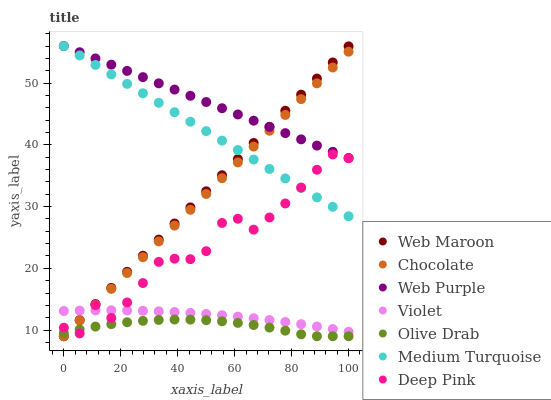Does Olive Drab have the minimum area under the curve?
Answer yes or no. Yes. Does Web Purple have the maximum area under the curve?
Answer yes or no. Yes. Does Web Maroon have the minimum area under the curve?
Answer yes or no. No. Does Web Maroon have the maximum area under the curve?
Answer yes or no. No. Is Chocolate the smoothest?
Answer yes or no. Yes. Is Deep Pink the roughest?
Answer yes or no. Yes. Is Web Maroon the smoothest?
Answer yes or no. No. Is Web Maroon the roughest?
Answer yes or no. No. Does Web Maroon have the lowest value?
Answer yes or no. Yes. Does Web Purple have the lowest value?
Answer yes or no. No. Does Medium Turquoise have the highest value?
Answer yes or no. Yes. Does Web Maroon have the highest value?
Answer yes or no. No. Is Violet less than Web Purple?
Answer yes or no. Yes. Is Violet greater than Olive Drab?
Answer yes or no. Yes. Does Medium Turquoise intersect Deep Pink?
Answer yes or no. Yes. Is Medium Turquoise less than Deep Pink?
Answer yes or no. No. Is Medium Turquoise greater than Deep Pink?
Answer yes or no. No. Does Violet intersect Web Purple?
Answer yes or no. No. 